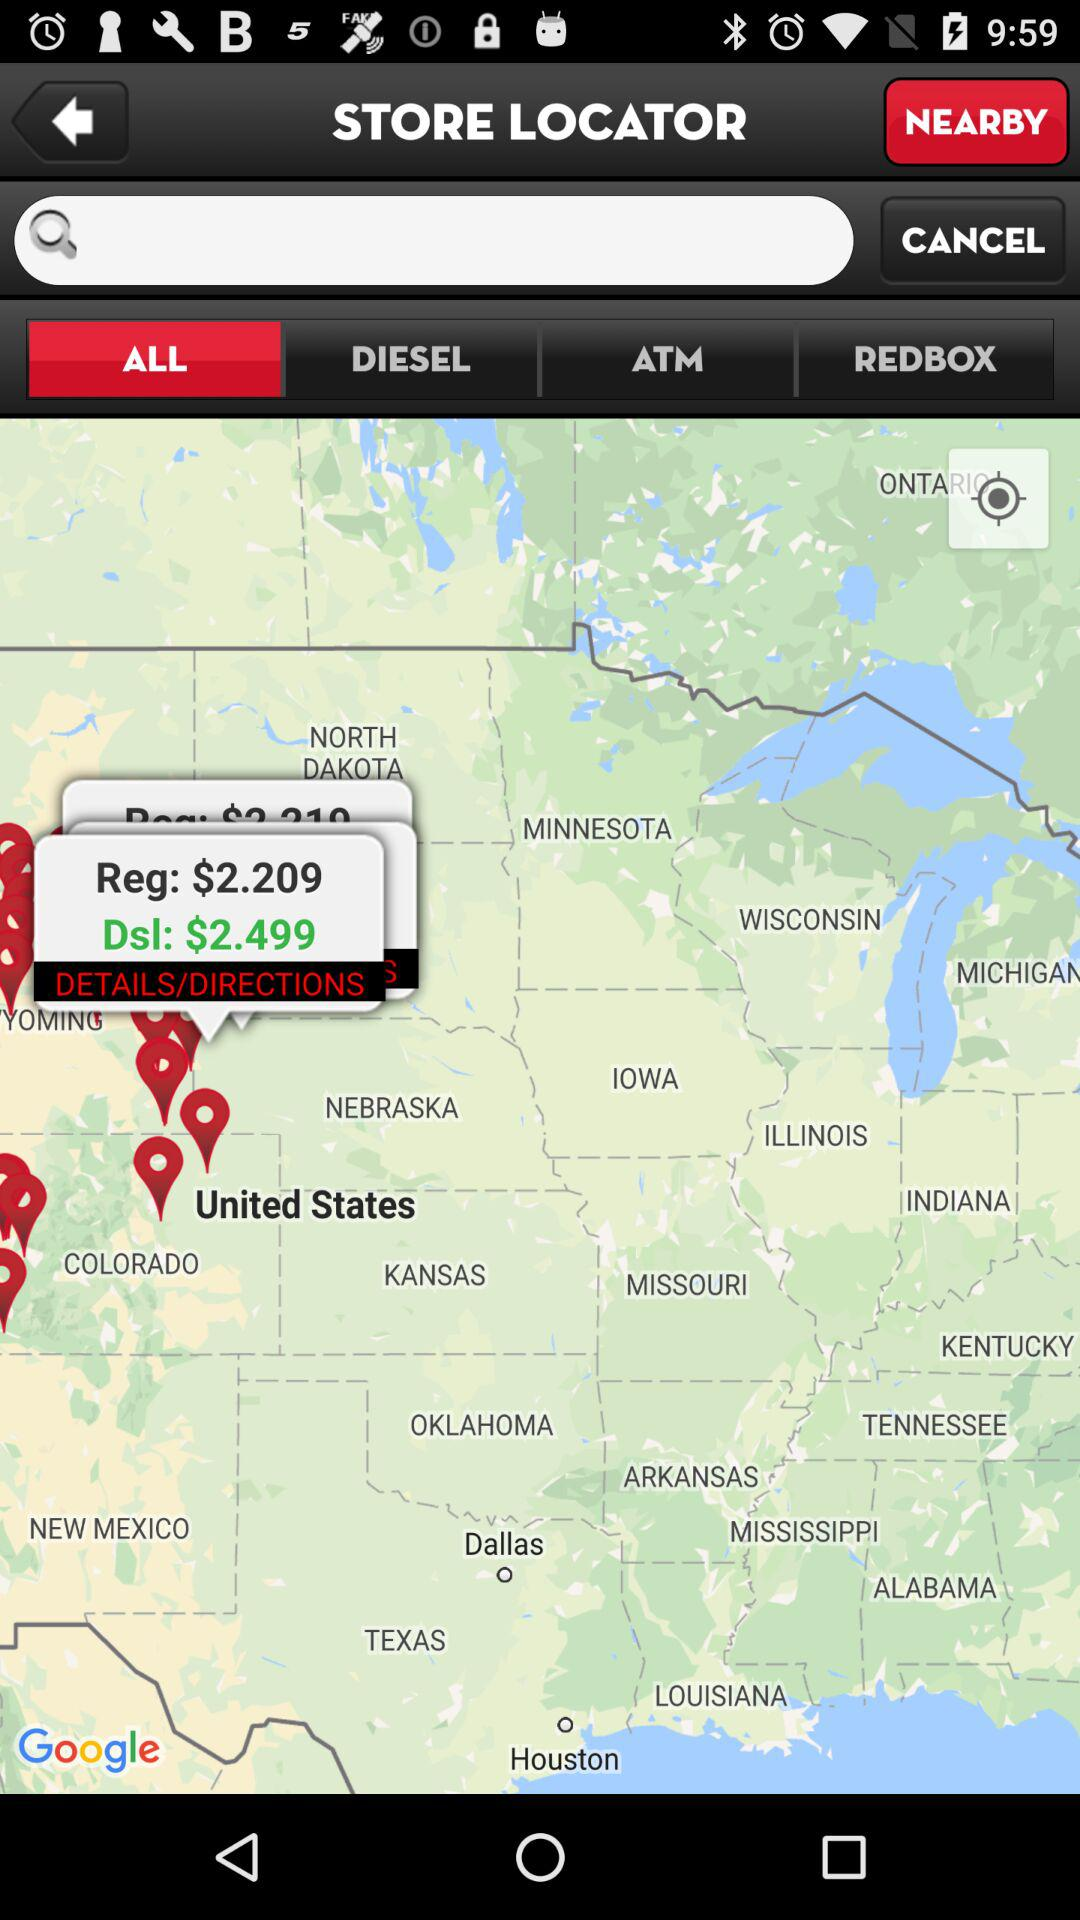How much more is the Dsl than the Reg?
Answer the question using a single word or phrase. $290 